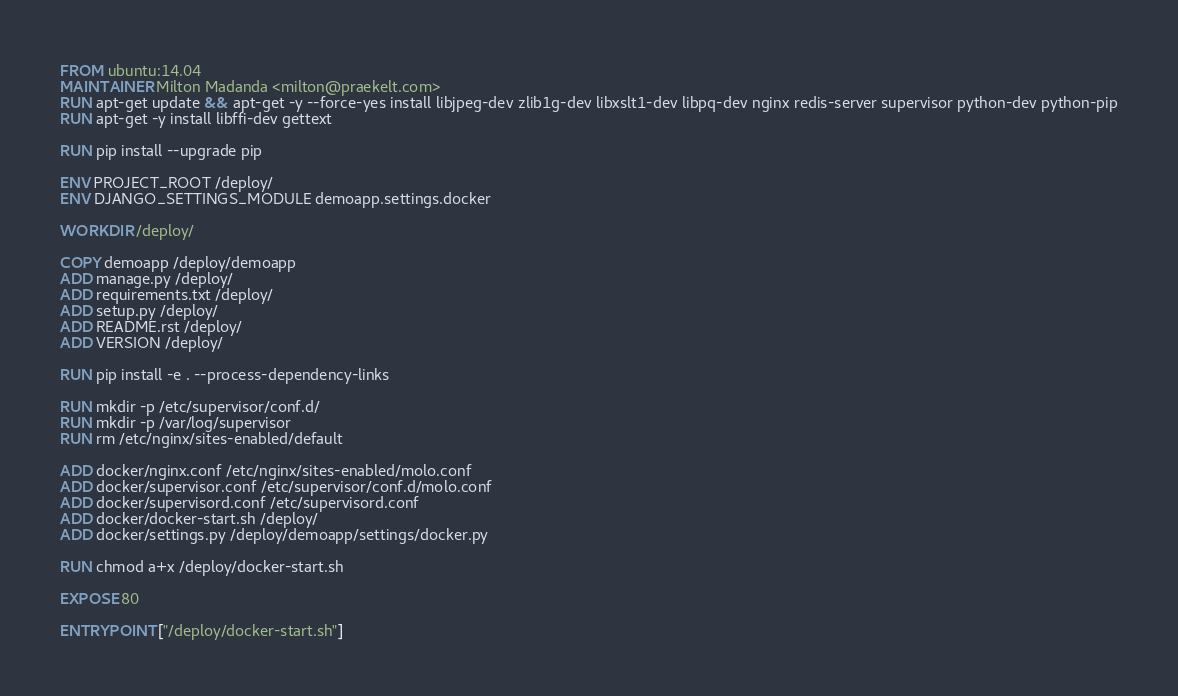<code> <loc_0><loc_0><loc_500><loc_500><_Dockerfile_>FROM ubuntu:14.04
MAINTAINER Milton Madanda <milton@praekelt.com>
RUN apt-get update && apt-get -y --force-yes install libjpeg-dev zlib1g-dev libxslt1-dev libpq-dev nginx redis-server supervisor python-dev python-pip
RUN apt-get -y install libffi-dev gettext

RUN pip install --upgrade pip

ENV PROJECT_ROOT /deploy/
ENV DJANGO_SETTINGS_MODULE demoapp.settings.docker

WORKDIR /deploy/

COPY demoapp /deploy/demoapp
ADD manage.py /deploy/
ADD requirements.txt /deploy/
ADD setup.py /deploy/
ADD README.rst /deploy/
ADD VERSION /deploy/

RUN pip install -e . --process-dependency-links

RUN mkdir -p /etc/supervisor/conf.d/
RUN mkdir -p /var/log/supervisor
RUN rm /etc/nginx/sites-enabled/default

ADD docker/nginx.conf /etc/nginx/sites-enabled/molo.conf
ADD docker/supervisor.conf /etc/supervisor/conf.d/molo.conf
ADD docker/supervisord.conf /etc/supervisord.conf
ADD docker/docker-start.sh /deploy/
ADD docker/settings.py /deploy/demoapp/settings/docker.py

RUN chmod a+x /deploy/docker-start.sh

EXPOSE 80

ENTRYPOINT ["/deploy/docker-start.sh"]
</code> 